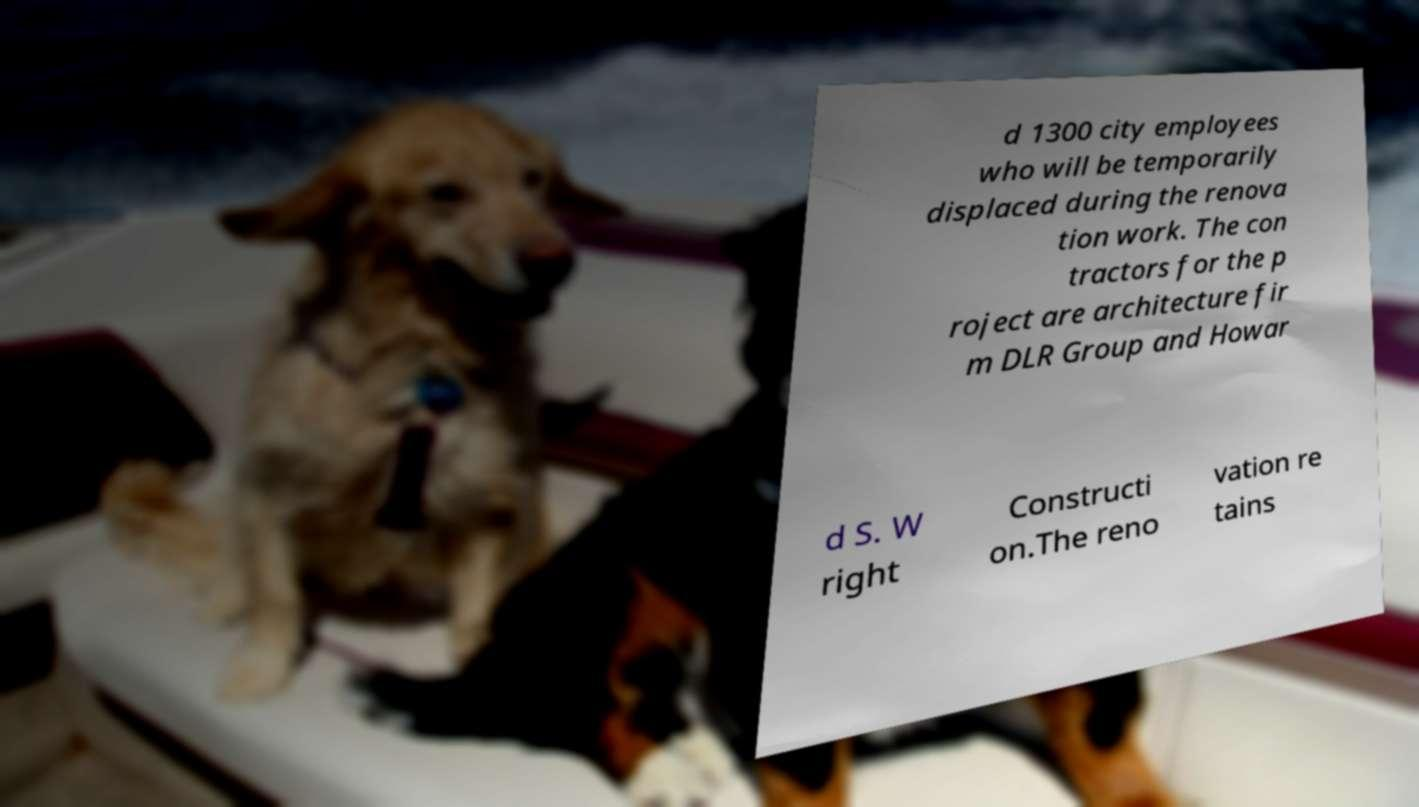Could you assist in decoding the text presented in this image and type it out clearly? d 1300 city employees who will be temporarily displaced during the renova tion work. The con tractors for the p roject are architecture fir m DLR Group and Howar d S. W right Constructi on.The reno vation re tains 